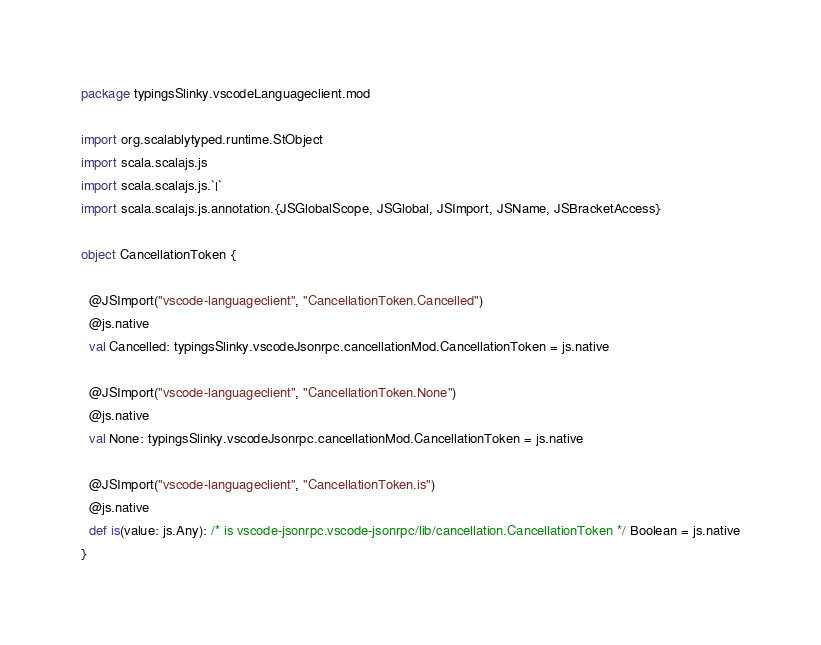Convert code to text. <code><loc_0><loc_0><loc_500><loc_500><_Scala_>package typingsSlinky.vscodeLanguageclient.mod

import org.scalablytyped.runtime.StObject
import scala.scalajs.js
import scala.scalajs.js.`|`
import scala.scalajs.js.annotation.{JSGlobalScope, JSGlobal, JSImport, JSName, JSBracketAccess}

object CancellationToken {
  
  @JSImport("vscode-languageclient", "CancellationToken.Cancelled")
  @js.native
  val Cancelled: typingsSlinky.vscodeJsonrpc.cancellationMod.CancellationToken = js.native
  
  @JSImport("vscode-languageclient", "CancellationToken.None")
  @js.native
  val None: typingsSlinky.vscodeJsonrpc.cancellationMod.CancellationToken = js.native
  
  @JSImport("vscode-languageclient", "CancellationToken.is")
  @js.native
  def is(value: js.Any): /* is vscode-jsonrpc.vscode-jsonrpc/lib/cancellation.CancellationToken */ Boolean = js.native
}
</code> 